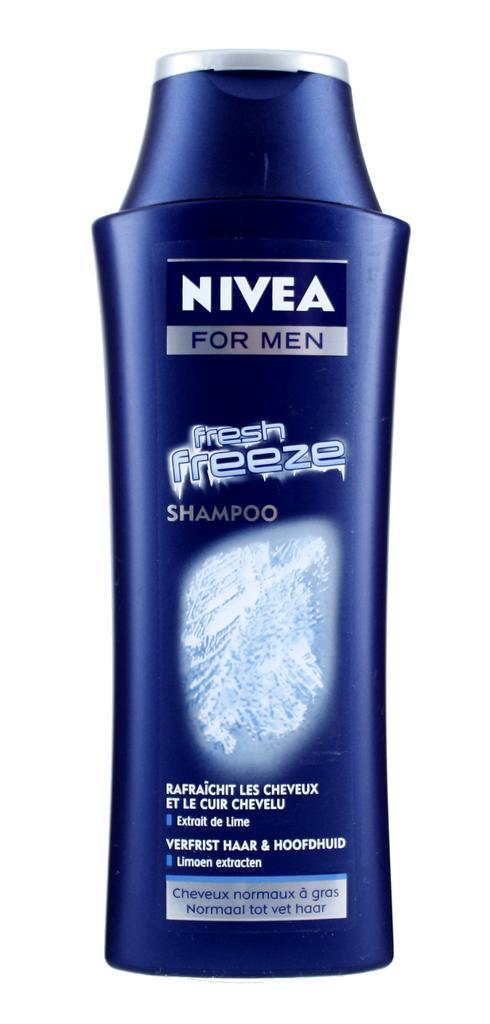How would you summarize this image in a sentence or two? In this image we can see a Nivea shampoo bottle. In the background the image is white in color. 